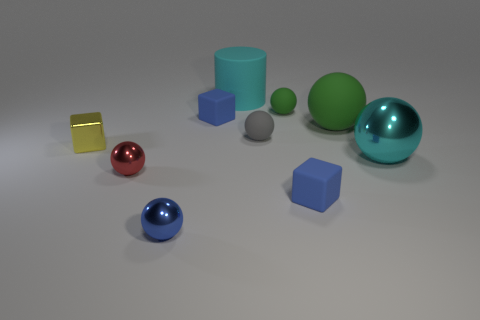What number of tiny things are either green matte objects or yellow metallic objects?
Your answer should be very brief. 2. How big is the red object?
Your response must be concise. Small. What number of matte cylinders are in front of the tiny red shiny object?
Offer a terse response. 0. There is a red shiny object that is the same shape as the large green thing; what is its size?
Your response must be concise. Small. There is a sphere that is both in front of the small gray ball and to the right of the big cyan cylinder; what size is it?
Keep it short and to the point. Large. Is the color of the tiny metal block the same as the small rubber cube in front of the tiny yellow metal thing?
Offer a terse response. No. What number of yellow objects are either metallic cubes or small matte blocks?
Provide a succinct answer. 1. What shape is the cyan matte object?
Provide a succinct answer. Cylinder. What number of other objects are there of the same shape as the tiny gray thing?
Provide a succinct answer. 5. There is a big object that is behind the small green rubber object; what is its color?
Give a very brief answer. Cyan. 